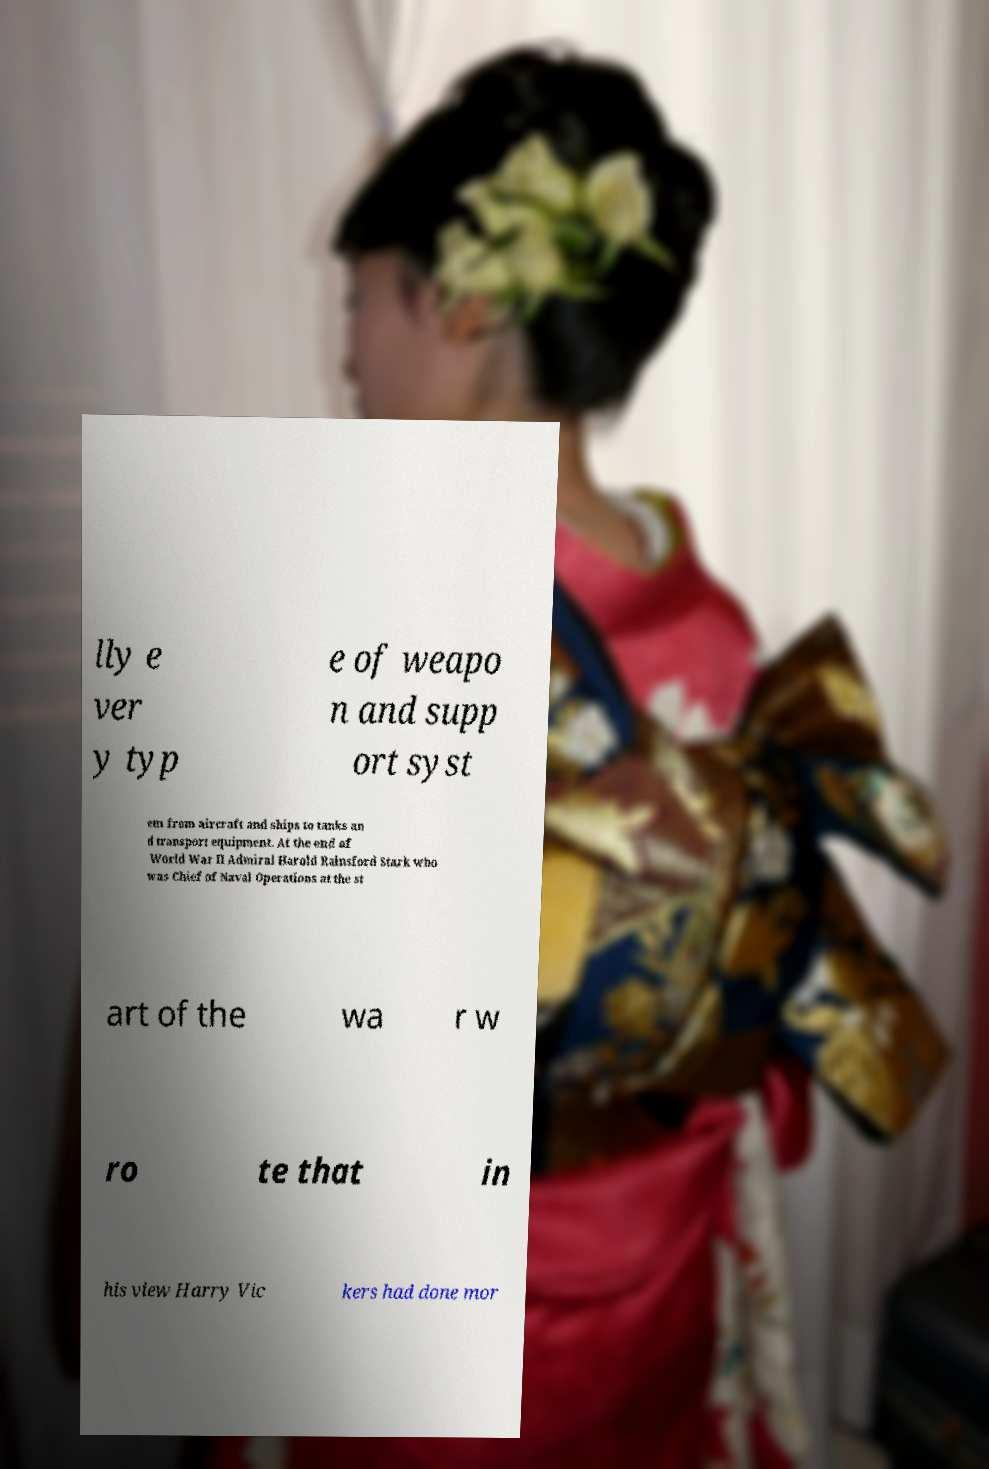I need the written content from this picture converted into text. Can you do that? lly e ver y typ e of weapo n and supp ort syst em from aircraft and ships to tanks an d transport equipment. At the end of World War II Admiral Harold Rainsford Stark who was Chief of Naval Operations at the st art of the wa r w ro te that in his view Harry Vic kers had done mor 